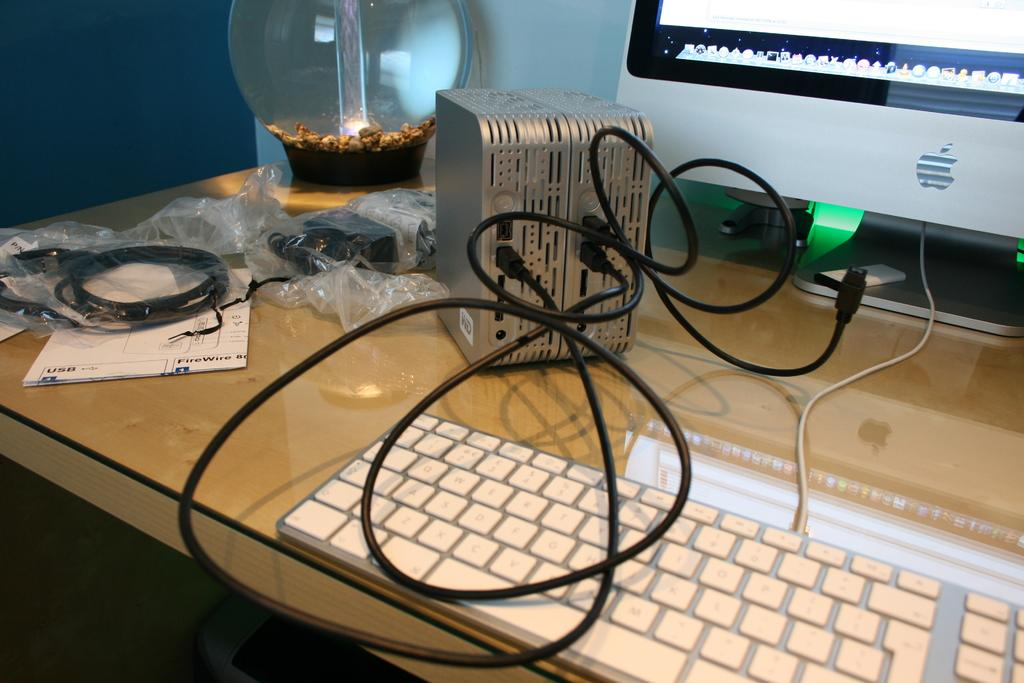What piece of furniture is present in the image? There is a desk in the image. What electronic device is on the desk? There is a monitor screen on the desk. What is used for typing on the computer? There is a keyboard on the desk. What can be seen connecting the devices on the desk? There are wires visible in the image. What is placed on the desk for writing or reading? There is a paper on the desk. What type of decorative item is present on the desk? There is a showpiece glass container in the image. What type of leather material is used to cover the oven in the image? There is no oven present in the image, and therefore no leather material can be observed. How many bells are hanging from the showpiece glass container in the image? There are no bells present in the image; only a showpiece glass container is visible. 